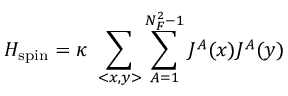Convert formula to latex. <formula><loc_0><loc_0><loc_500><loc_500>H _ { s p i n } = \kappa \sum _ { < x , y > } \sum _ { A = 1 } ^ { N _ { F } ^ { 2 } - 1 } J ^ { A } ( x ) J ^ { A } ( y )</formula> 